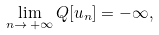<formula> <loc_0><loc_0><loc_500><loc_500>\lim _ { n \rightarrow \, + \infty } Q [ u _ { n } ] = - \infty ,</formula> 